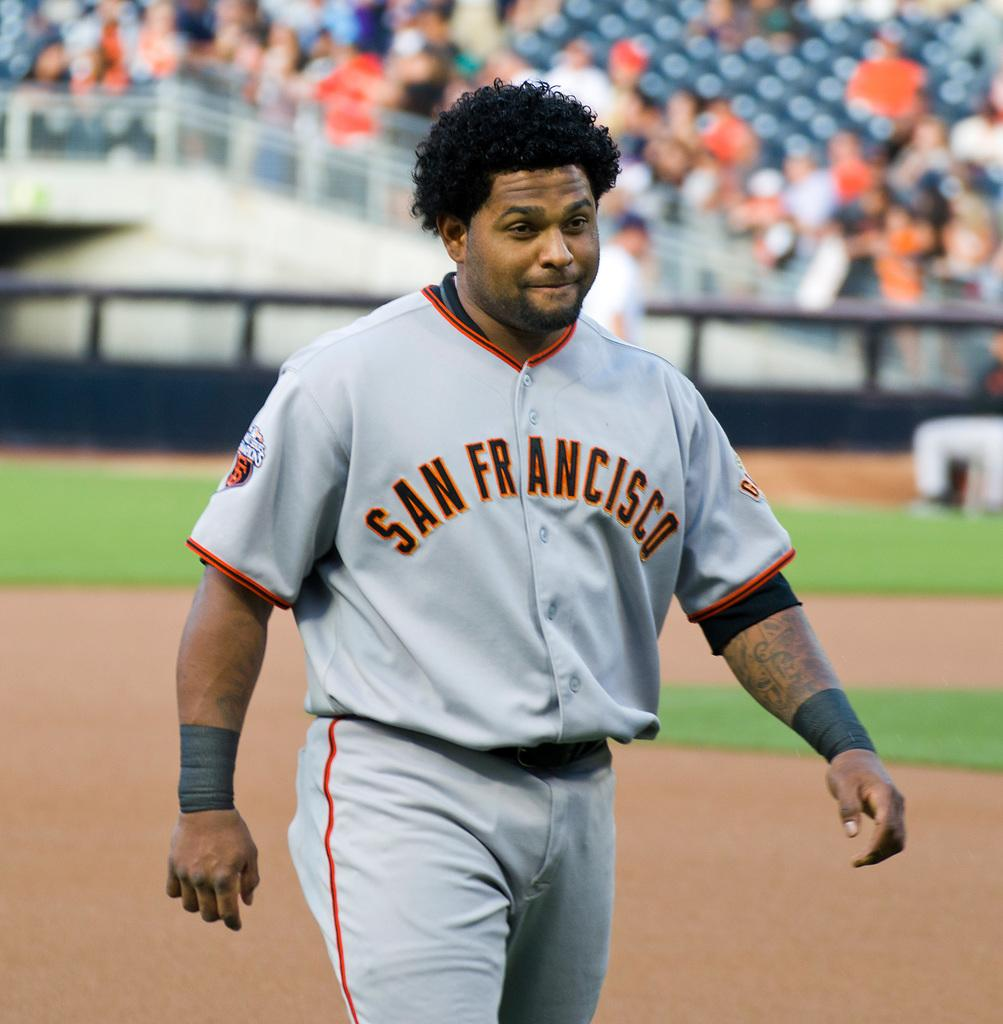<image>
Write a terse but informative summary of the picture. a San Francisco baseball player strutting on the field 